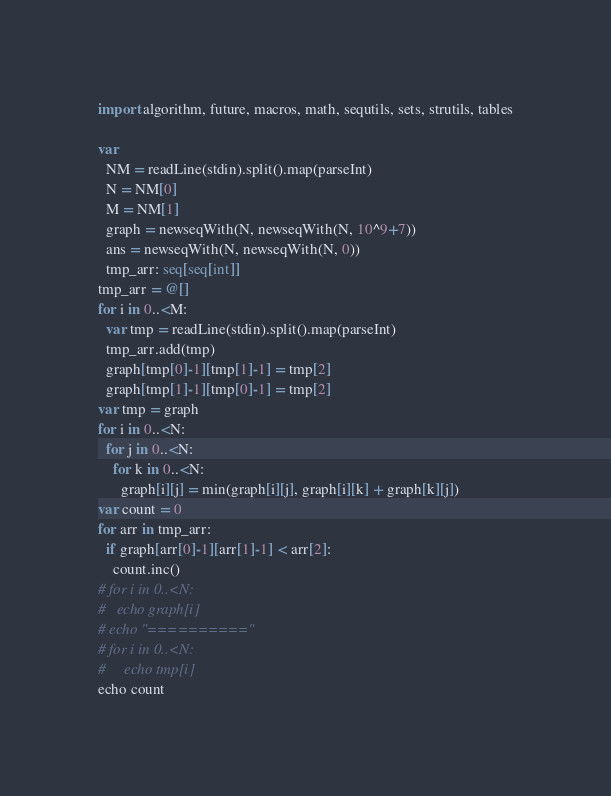<code> <loc_0><loc_0><loc_500><loc_500><_Nim_>import algorithm, future, macros, math, sequtils, sets, strutils, tables

var
  NM = readLine(stdin).split().map(parseInt)
  N = NM[0]
  M = NM[1]
  graph = newseqWith(N, newseqWith(N, 10^9+7))
  ans = newseqWith(N, newseqWith(N, 0))
  tmp_arr: seq[seq[int]]
tmp_arr = @[]
for i in 0..<M:
  var tmp = readLine(stdin).split().map(parseInt)
  tmp_arr.add(tmp)
  graph[tmp[0]-1][tmp[1]-1] = tmp[2]
  graph[tmp[1]-1][tmp[0]-1] = tmp[2]
var tmp = graph
for i in 0..<N:
  for j in 0..<N:
    for k in 0..<N:
      graph[i][j] = min(graph[i][j], graph[i][k] + graph[k][j])
var count = 0
for arr in tmp_arr:
  if graph[arr[0]-1][arr[1]-1] < arr[2]:
    count.inc()
# for i in 0..<N:
#   echo graph[i]
# echo "=========="
# for i in 0..<N:
#     echo tmp[i]
echo count
</code> 